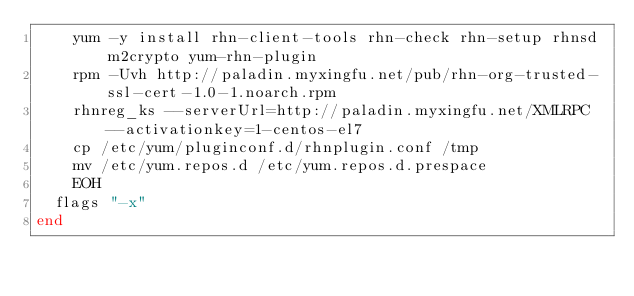<code> <loc_0><loc_0><loc_500><loc_500><_Ruby_>    yum -y install rhn-client-tools rhn-check rhn-setup rhnsd m2crypto yum-rhn-plugin
    rpm -Uvh http://paladin.myxingfu.net/pub/rhn-org-trusted-ssl-cert-1.0-1.noarch.rpm
    rhnreg_ks --serverUrl=http://paladin.myxingfu.net/XMLRPC --activationkey=1-centos-el7
    cp /etc/yum/pluginconf.d/rhnplugin.conf /tmp
    mv /etc/yum.repos.d /etc/yum.repos.d.prespace
    EOH
  flags "-x"
end

</code> 